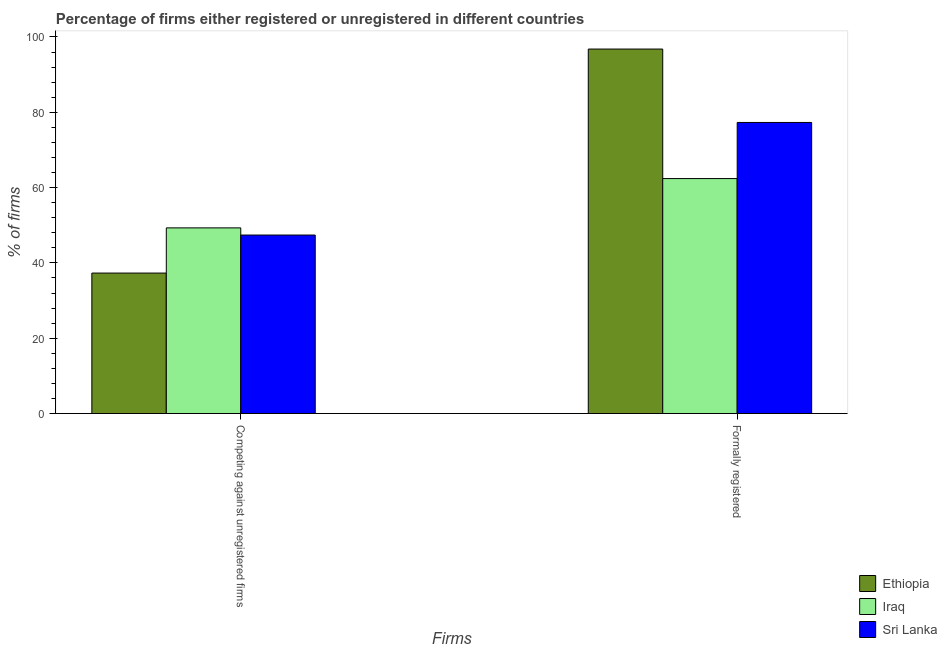How many different coloured bars are there?
Ensure brevity in your answer.  3. How many groups of bars are there?
Keep it short and to the point. 2. Are the number of bars on each tick of the X-axis equal?
Provide a succinct answer. Yes. How many bars are there on the 1st tick from the left?
Ensure brevity in your answer.  3. How many bars are there on the 2nd tick from the right?
Offer a terse response. 3. What is the label of the 2nd group of bars from the left?
Your response must be concise. Formally registered. What is the percentage of registered firms in Sri Lanka?
Provide a short and direct response. 47.4. Across all countries, what is the maximum percentage of registered firms?
Provide a succinct answer. 49.3. Across all countries, what is the minimum percentage of registered firms?
Offer a very short reply. 37.3. In which country was the percentage of registered firms maximum?
Your answer should be very brief. Iraq. In which country was the percentage of formally registered firms minimum?
Ensure brevity in your answer.  Iraq. What is the total percentage of registered firms in the graph?
Your answer should be very brief. 134. What is the difference between the percentage of registered firms in Sri Lanka and that in Iraq?
Provide a succinct answer. -1.9. What is the average percentage of formally registered firms per country?
Provide a succinct answer. 78.83. What is the difference between the percentage of registered firms and percentage of formally registered firms in Sri Lanka?
Provide a short and direct response. -29.9. What is the ratio of the percentage of formally registered firms in Ethiopia to that in Sri Lanka?
Your answer should be compact. 1.25. What does the 2nd bar from the left in Formally registered represents?
Make the answer very short. Iraq. What does the 1st bar from the right in Formally registered represents?
Make the answer very short. Sri Lanka. Are all the bars in the graph horizontal?
Provide a succinct answer. No. How many countries are there in the graph?
Ensure brevity in your answer.  3. Does the graph contain grids?
Give a very brief answer. No. Where does the legend appear in the graph?
Your answer should be very brief. Bottom right. How are the legend labels stacked?
Your response must be concise. Vertical. What is the title of the graph?
Keep it short and to the point. Percentage of firms either registered or unregistered in different countries. What is the label or title of the X-axis?
Make the answer very short. Firms. What is the label or title of the Y-axis?
Your answer should be compact. % of firms. What is the % of firms of Ethiopia in Competing against unregistered firms?
Keep it short and to the point. 37.3. What is the % of firms in Iraq in Competing against unregistered firms?
Your answer should be very brief. 49.3. What is the % of firms of Sri Lanka in Competing against unregistered firms?
Make the answer very short. 47.4. What is the % of firms of Ethiopia in Formally registered?
Your response must be concise. 96.8. What is the % of firms in Iraq in Formally registered?
Offer a very short reply. 62.4. What is the % of firms of Sri Lanka in Formally registered?
Provide a short and direct response. 77.3. Across all Firms, what is the maximum % of firms of Ethiopia?
Keep it short and to the point. 96.8. Across all Firms, what is the maximum % of firms in Iraq?
Offer a terse response. 62.4. Across all Firms, what is the maximum % of firms of Sri Lanka?
Your answer should be compact. 77.3. Across all Firms, what is the minimum % of firms of Ethiopia?
Give a very brief answer. 37.3. Across all Firms, what is the minimum % of firms in Iraq?
Keep it short and to the point. 49.3. Across all Firms, what is the minimum % of firms in Sri Lanka?
Your answer should be compact. 47.4. What is the total % of firms of Ethiopia in the graph?
Your response must be concise. 134.1. What is the total % of firms of Iraq in the graph?
Ensure brevity in your answer.  111.7. What is the total % of firms in Sri Lanka in the graph?
Provide a short and direct response. 124.7. What is the difference between the % of firms of Ethiopia in Competing against unregistered firms and that in Formally registered?
Your answer should be compact. -59.5. What is the difference between the % of firms of Sri Lanka in Competing against unregistered firms and that in Formally registered?
Provide a short and direct response. -29.9. What is the difference between the % of firms in Ethiopia in Competing against unregistered firms and the % of firms in Iraq in Formally registered?
Provide a succinct answer. -25.1. What is the average % of firms of Ethiopia per Firms?
Your response must be concise. 67.05. What is the average % of firms of Iraq per Firms?
Give a very brief answer. 55.85. What is the average % of firms in Sri Lanka per Firms?
Ensure brevity in your answer.  62.35. What is the difference between the % of firms of Ethiopia and % of firms of Iraq in Formally registered?
Offer a terse response. 34.4. What is the difference between the % of firms in Iraq and % of firms in Sri Lanka in Formally registered?
Your answer should be very brief. -14.9. What is the ratio of the % of firms in Ethiopia in Competing against unregistered firms to that in Formally registered?
Provide a short and direct response. 0.39. What is the ratio of the % of firms in Iraq in Competing against unregistered firms to that in Formally registered?
Offer a terse response. 0.79. What is the ratio of the % of firms in Sri Lanka in Competing against unregistered firms to that in Formally registered?
Your response must be concise. 0.61. What is the difference between the highest and the second highest % of firms of Ethiopia?
Offer a very short reply. 59.5. What is the difference between the highest and the second highest % of firms of Sri Lanka?
Provide a succinct answer. 29.9. What is the difference between the highest and the lowest % of firms of Ethiopia?
Provide a succinct answer. 59.5. What is the difference between the highest and the lowest % of firms of Sri Lanka?
Your response must be concise. 29.9. 